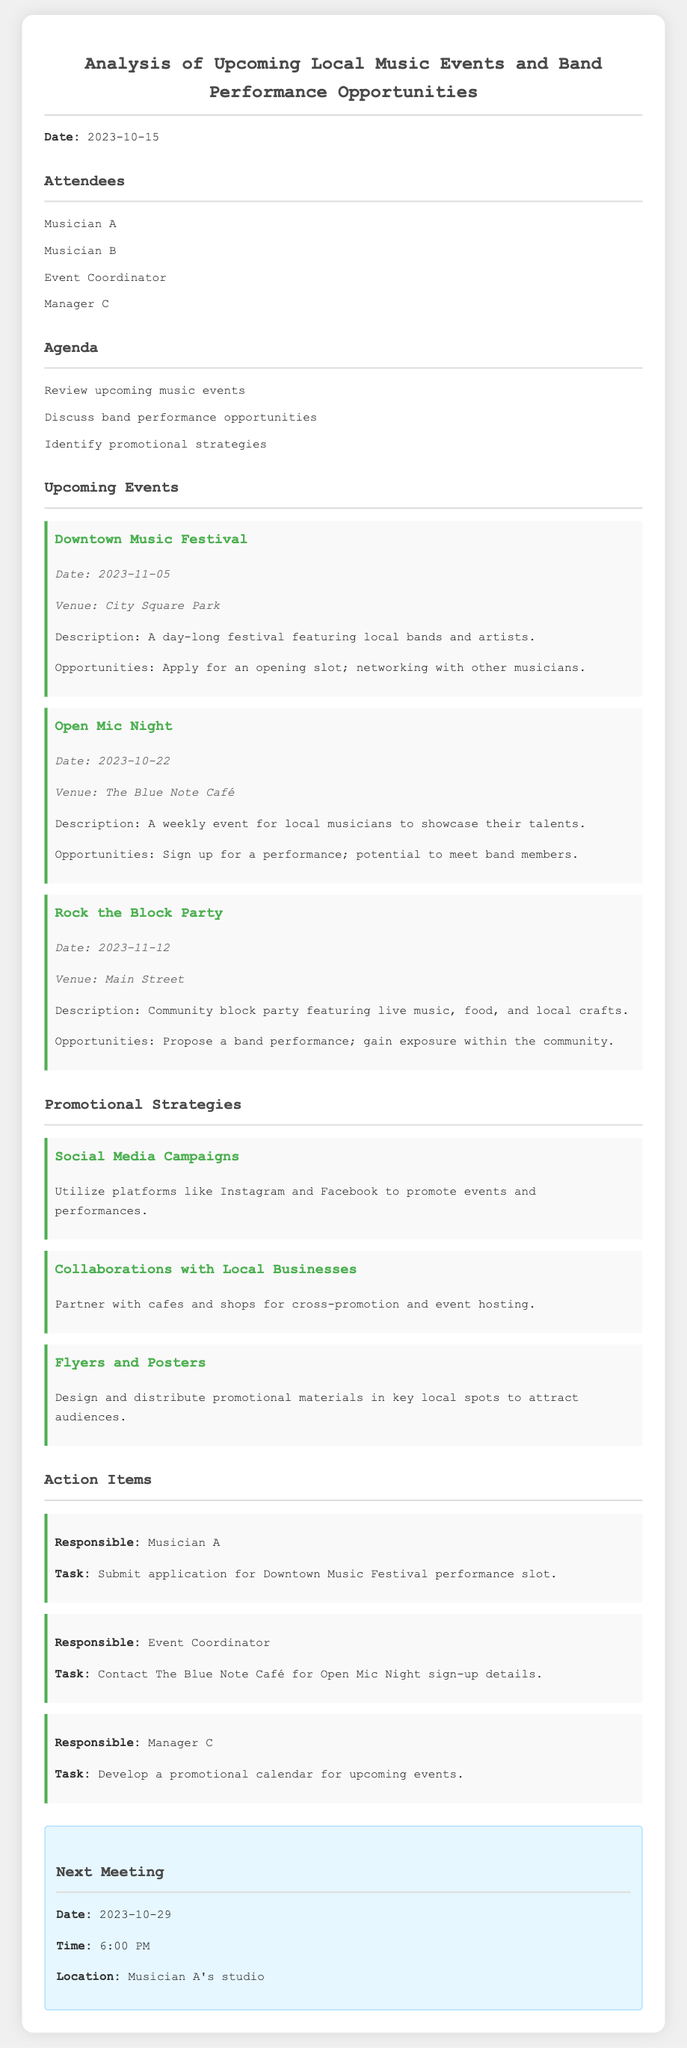what is the date of the Downtown Music Festival? The date is specified in the document under the upcoming events section.
Answer: 2023-11-05 who is responsible for submitting the application for the Downtown Music Festival performance slot? This information is found in the action items, where responsibilities are assigned to specific individuals.
Answer: Musician A what is the venue for the Open Mic Night? The venue is mentioned in the details of the Open Mic Night event in the upcoming events section.
Answer: The Blue Note Café what type of event is scheduled for 2023-11-12? This requires understanding the event details listed for that date in the upcoming events section.
Answer: Rock the Block Party how will local music events be promoted according to the document? This is addressed in the promotional strategies section where various methods are suggested.
Answer: Social Media Campaigns what is the date and time of the next meeting? The next meeting details are outlined at the end of the document.
Answer: 2023-10-29, 6:00 PM how many attendees were present at the meeting? This can be deduced from the attendees listed at the beginning of the document.
Answer: Four which musician is tasked with developing a promotional calendar? The answer is found in the action items section where tasks are assigned.
Answer: Manager C what description is provided for the Downtown Music Festival? The description can be found within the details of the Downtown Music Festival under upcoming events.
Answer: A day-long festival featuring local bands and artists 